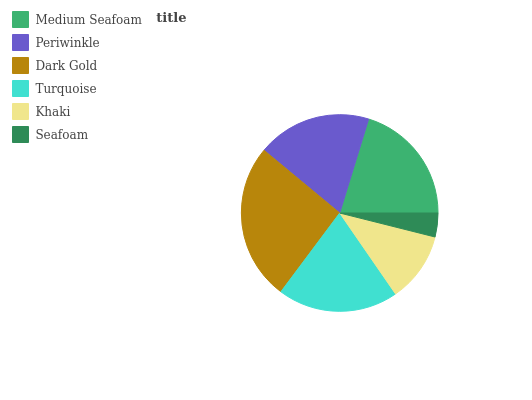Is Seafoam the minimum?
Answer yes or no. Yes. Is Dark Gold the maximum?
Answer yes or no. Yes. Is Periwinkle the minimum?
Answer yes or no. No. Is Periwinkle the maximum?
Answer yes or no. No. Is Medium Seafoam greater than Periwinkle?
Answer yes or no. Yes. Is Periwinkle less than Medium Seafoam?
Answer yes or no. Yes. Is Periwinkle greater than Medium Seafoam?
Answer yes or no. No. Is Medium Seafoam less than Periwinkle?
Answer yes or no. No. Is Turquoise the high median?
Answer yes or no. Yes. Is Periwinkle the low median?
Answer yes or no. Yes. Is Periwinkle the high median?
Answer yes or no. No. Is Medium Seafoam the low median?
Answer yes or no. No. 